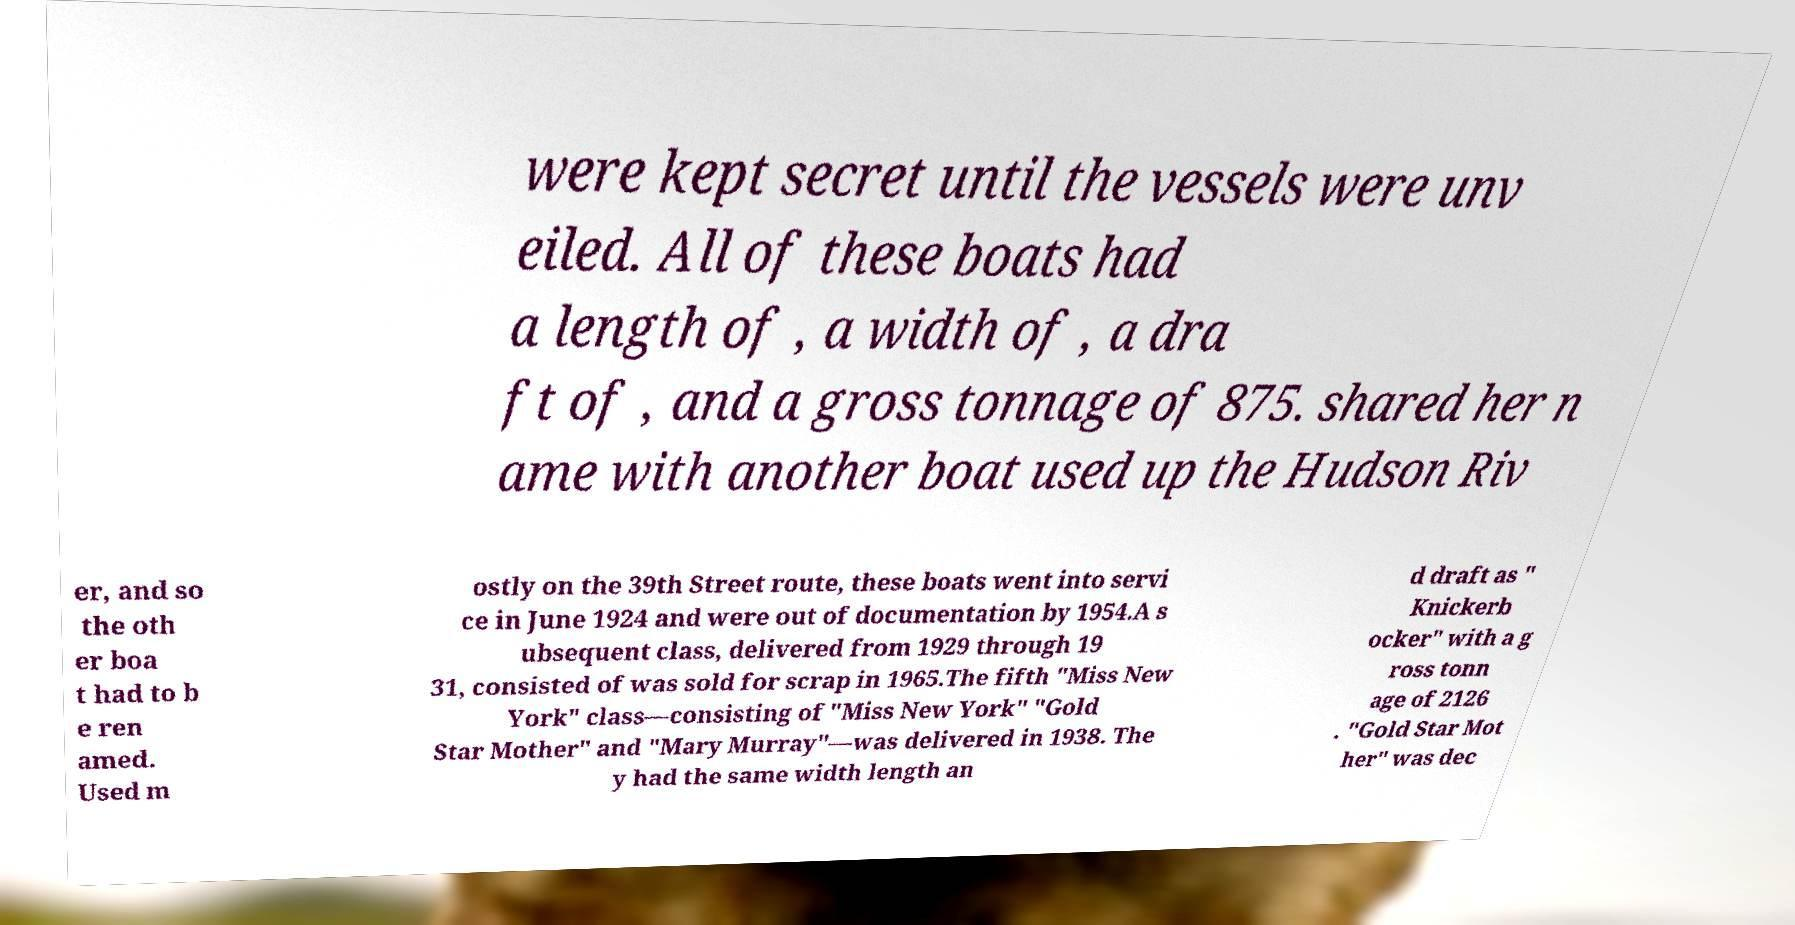For documentation purposes, I need the text within this image transcribed. Could you provide that? were kept secret until the vessels were unv eiled. All of these boats had a length of , a width of , a dra ft of , and a gross tonnage of 875. shared her n ame with another boat used up the Hudson Riv er, and so the oth er boa t had to b e ren amed. Used m ostly on the 39th Street route, these boats went into servi ce in June 1924 and were out of documentation by 1954.A s ubsequent class, delivered from 1929 through 19 31, consisted of was sold for scrap in 1965.The fifth "Miss New York" class—consisting of "Miss New York" "Gold Star Mother" and "Mary Murray"—was delivered in 1938. The y had the same width length an d draft as " Knickerb ocker" with a g ross tonn age of 2126 . "Gold Star Mot her" was dec 